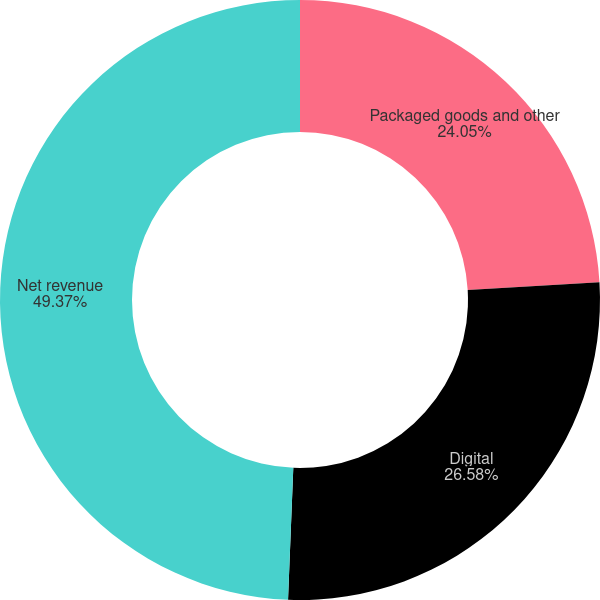Convert chart. <chart><loc_0><loc_0><loc_500><loc_500><pie_chart><fcel>Packaged goods and other<fcel>Digital<fcel>Net revenue<nl><fcel>24.05%<fcel>26.58%<fcel>49.36%<nl></chart> 